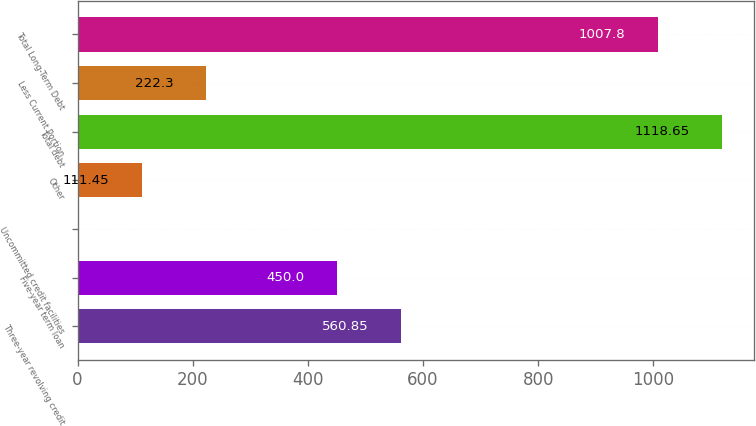Convert chart to OTSL. <chart><loc_0><loc_0><loc_500><loc_500><bar_chart><fcel>Three-year revolving credit<fcel>Five-year term loan<fcel>Uncommitted credit facilities<fcel>Other<fcel>Total debt<fcel>Less Current Portion<fcel>Total Long-Term Debt<nl><fcel>560.85<fcel>450<fcel>0.6<fcel>111.45<fcel>1118.65<fcel>222.3<fcel>1007.8<nl></chart> 